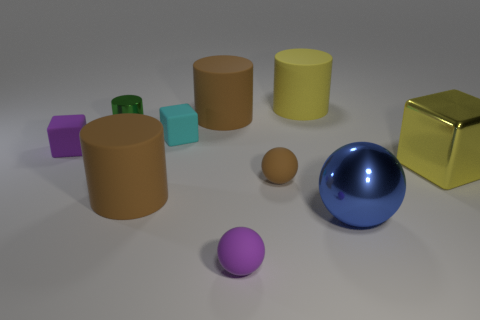How many small cyan rubber objects have the same shape as the yellow metal object?
Give a very brief answer. 1. There is a cylinder that is the same color as the large metal cube; what material is it?
Your answer should be compact. Rubber. Are the cyan cube and the big block made of the same material?
Offer a terse response. No. There is a big yellow rubber cylinder that is on the right side of the small matte block that is left of the tiny metallic cylinder; how many shiny blocks are to the right of it?
Offer a terse response. 1. Are there any cyan objects made of the same material as the tiny purple block?
Your response must be concise. Yes. Is the number of tiny brown objects less than the number of large gray shiny things?
Ensure brevity in your answer.  No. Do the cylinder right of the tiny brown object and the large metallic block have the same color?
Provide a succinct answer. Yes. There is a brown thing that is behind the tiny purple matte thing that is behind the metallic thing right of the big blue shiny sphere; what is it made of?
Keep it short and to the point. Rubber. Are there any rubber cylinders of the same color as the shiny cube?
Provide a short and direct response. Yes. Is the number of purple matte balls behind the small cyan cube less than the number of cyan balls?
Offer a terse response. No. 